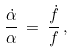Convert formula to latex. <formula><loc_0><loc_0><loc_500><loc_500>\frac { \dot { \alpha } } { \alpha } \, = \, \frac { \dot { f } } { f } \, ,</formula> 